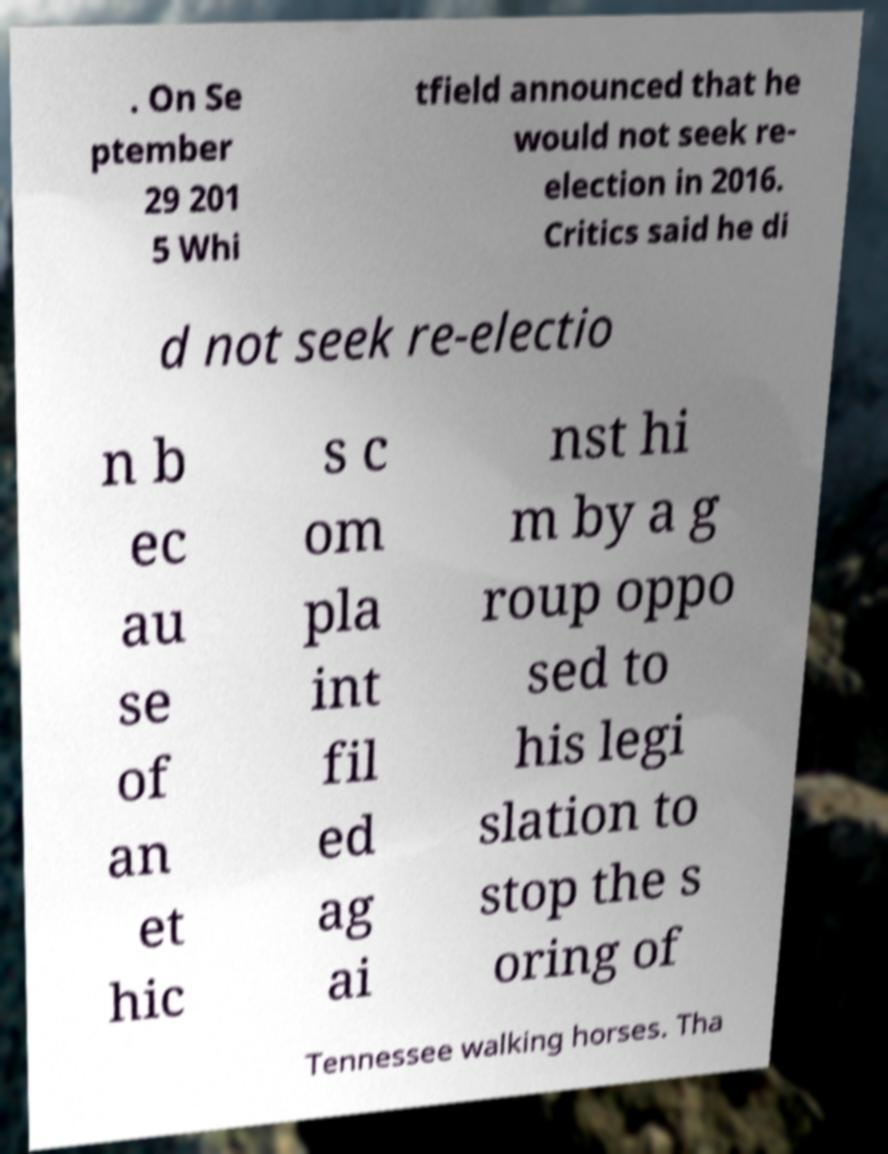Can you accurately transcribe the text from the provided image for me? . On Se ptember 29 201 5 Whi tfield announced that he would not seek re- election in 2016. Critics said he di d not seek re-electio n b ec au se of an et hic s c om pla int fil ed ag ai nst hi m by a g roup oppo sed to his legi slation to stop the s oring of Tennessee walking horses. Tha 